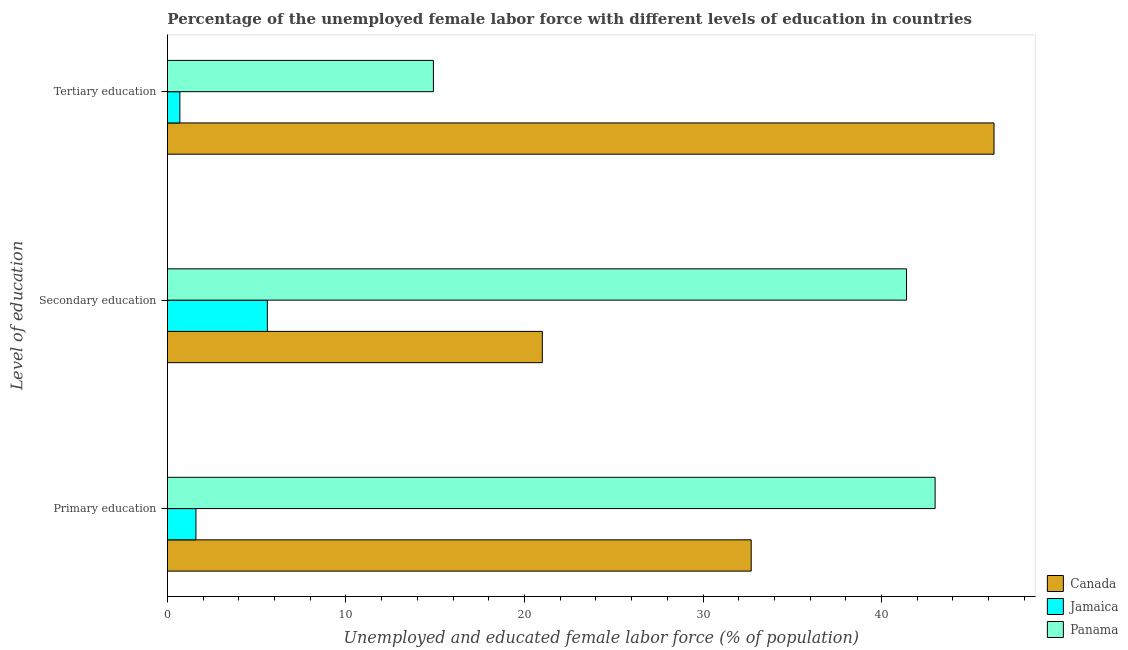How many different coloured bars are there?
Provide a succinct answer. 3. Are the number of bars per tick equal to the number of legend labels?
Make the answer very short. Yes. Are the number of bars on each tick of the Y-axis equal?
Keep it short and to the point. Yes. How many bars are there on the 1st tick from the top?
Ensure brevity in your answer.  3. What is the label of the 2nd group of bars from the top?
Provide a short and direct response. Secondary education. What is the percentage of female labor force who received primary education in Jamaica?
Your answer should be very brief. 1.6. Across all countries, what is the maximum percentage of female labor force who received tertiary education?
Offer a very short reply. 46.3. Across all countries, what is the minimum percentage of female labor force who received tertiary education?
Provide a short and direct response. 0.7. In which country was the percentage of female labor force who received secondary education maximum?
Give a very brief answer. Panama. In which country was the percentage of female labor force who received tertiary education minimum?
Offer a very short reply. Jamaica. What is the total percentage of female labor force who received tertiary education in the graph?
Your answer should be compact. 61.9. What is the difference between the percentage of female labor force who received primary education in Canada and that in Jamaica?
Your response must be concise. 31.1. What is the difference between the percentage of female labor force who received tertiary education in Canada and the percentage of female labor force who received secondary education in Panama?
Provide a short and direct response. 4.9. What is the average percentage of female labor force who received primary education per country?
Ensure brevity in your answer.  25.77. What is the difference between the percentage of female labor force who received secondary education and percentage of female labor force who received tertiary education in Canada?
Your response must be concise. -25.3. What is the ratio of the percentage of female labor force who received primary education in Panama to that in Jamaica?
Offer a very short reply. 26.87. Is the difference between the percentage of female labor force who received primary education in Jamaica and Panama greater than the difference between the percentage of female labor force who received secondary education in Jamaica and Panama?
Ensure brevity in your answer.  No. What is the difference between the highest and the second highest percentage of female labor force who received secondary education?
Offer a terse response. 20.4. What is the difference between the highest and the lowest percentage of female labor force who received tertiary education?
Your answer should be very brief. 45.6. In how many countries, is the percentage of female labor force who received primary education greater than the average percentage of female labor force who received primary education taken over all countries?
Keep it short and to the point. 2. Is the sum of the percentage of female labor force who received tertiary education in Canada and Panama greater than the maximum percentage of female labor force who received primary education across all countries?
Your answer should be compact. Yes. What does the 2nd bar from the top in Secondary education represents?
Give a very brief answer. Jamaica. What does the 1st bar from the bottom in Primary education represents?
Your answer should be compact. Canada. Is it the case that in every country, the sum of the percentage of female labor force who received primary education and percentage of female labor force who received secondary education is greater than the percentage of female labor force who received tertiary education?
Offer a terse response. Yes. Are all the bars in the graph horizontal?
Offer a terse response. Yes. How many countries are there in the graph?
Provide a short and direct response. 3. How many legend labels are there?
Keep it short and to the point. 3. How are the legend labels stacked?
Offer a terse response. Vertical. What is the title of the graph?
Provide a succinct answer. Percentage of the unemployed female labor force with different levels of education in countries. Does "Kazakhstan" appear as one of the legend labels in the graph?
Your answer should be compact. No. What is the label or title of the X-axis?
Make the answer very short. Unemployed and educated female labor force (% of population). What is the label or title of the Y-axis?
Offer a very short reply. Level of education. What is the Unemployed and educated female labor force (% of population) in Canada in Primary education?
Make the answer very short. 32.7. What is the Unemployed and educated female labor force (% of population) in Jamaica in Primary education?
Provide a short and direct response. 1.6. What is the Unemployed and educated female labor force (% of population) of Panama in Primary education?
Provide a short and direct response. 43. What is the Unemployed and educated female labor force (% of population) of Canada in Secondary education?
Provide a short and direct response. 21. What is the Unemployed and educated female labor force (% of population) in Jamaica in Secondary education?
Give a very brief answer. 5.6. What is the Unemployed and educated female labor force (% of population) in Panama in Secondary education?
Give a very brief answer. 41.4. What is the Unemployed and educated female labor force (% of population) of Canada in Tertiary education?
Give a very brief answer. 46.3. What is the Unemployed and educated female labor force (% of population) of Jamaica in Tertiary education?
Your answer should be compact. 0.7. What is the Unemployed and educated female labor force (% of population) of Panama in Tertiary education?
Make the answer very short. 14.9. Across all Level of education, what is the maximum Unemployed and educated female labor force (% of population) of Canada?
Make the answer very short. 46.3. Across all Level of education, what is the maximum Unemployed and educated female labor force (% of population) in Jamaica?
Your answer should be compact. 5.6. Across all Level of education, what is the minimum Unemployed and educated female labor force (% of population) in Jamaica?
Offer a terse response. 0.7. Across all Level of education, what is the minimum Unemployed and educated female labor force (% of population) of Panama?
Give a very brief answer. 14.9. What is the total Unemployed and educated female labor force (% of population) of Panama in the graph?
Offer a terse response. 99.3. What is the difference between the Unemployed and educated female labor force (% of population) of Canada in Primary education and that in Tertiary education?
Your response must be concise. -13.6. What is the difference between the Unemployed and educated female labor force (% of population) of Panama in Primary education and that in Tertiary education?
Your response must be concise. 28.1. What is the difference between the Unemployed and educated female labor force (% of population) in Canada in Secondary education and that in Tertiary education?
Offer a very short reply. -25.3. What is the difference between the Unemployed and educated female labor force (% of population) in Jamaica in Secondary education and that in Tertiary education?
Provide a succinct answer. 4.9. What is the difference between the Unemployed and educated female labor force (% of population) of Canada in Primary education and the Unemployed and educated female labor force (% of population) of Jamaica in Secondary education?
Your answer should be compact. 27.1. What is the difference between the Unemployed and educated female labor force (% of population) in Canada in Primary education and the Unemployed and educated female labor force (% of population) in Panama in Secondary education?
Keep it short and to the point. -8.7. What is the difference between the Unemployed and educated female labor force (% of population) in Jamaica in Primary education and the Unemployed and educated female labor force (% of population) in Panama in Secondary education?
Make the answer very short. -39.8. What is the difference between the Unemployed and educated female labor force (% of population) in Canada in Primary education and the Unemployed and educated female labor force (% of population) in Jamaica in Tertiary education?
Offer a terse response. 32. What is the difference between the Unemployed and educated female labor force (% of population) in Canada in Primary education and the Unemployed and educated female labor force (% of population) in Panama in Tertiary education?
Offer a terse response. 17.8. What is the difference between the Unemployed and educated female labor force (% of population) in Jamaica in Primary education and the Unemployed and educated female labor force (% of population) in Panama in Tertiary education?
Offer a very short reply. -13.3. What is the difference between the Unemployed and educated female labor force (% of population) in Canada in Secondary education and the Unemployed and educated female labor force (% of population) in Jamaica in Tertiary education?
Give a very brief answer. 20.3. What is the difference between the Unemployed and educated female labor force (% of population) in Canada in Secondary education and the Unemployed and educated female labor force (% of population) in Panama in Tertiary education?
Make the answer very short. 6.1. What is the average Unemployed and educated female labor force (% of population) in Canada per Level of education?
Your response must be concise. 33.33. What is the average Unemployed and educated female labor force (% of population) of Jamaica per Level of education?
Provide a succinct answer. 2.63. What is the average Unemployed and educated female labor force (% of population) in Panama per Level of education?
Provide a succinct answer. 33.1. What is the difference between the Unemployed and educated female labor force (% of population) of Canada and Unemployed and educated female labor force (% of population) of Jamaica in Primary education?
Your answer should be compact. 31.1. What is the difference between the Unemployed and educated female labor force (% of population) of Canada and Unemployed and educated female labor force (% of population) of Panama in Primary education?
Provide a short and direct response. -10.3. What is the difference between the Unemployed and educated female labor force (% of population) in Jamaica and Unemployed and educated female labor force (% of population) in Panama in Primary education?
Your response must be concise. -41.4. What is the difference between the Unemployed and educated female labor force (% of population) of Canada and Unemployed and educated female labor force (% of population) of Panama in Secondary education?
Your response must be concise. -20.4. What is the difference between the Unemployed and educated female labor force (% of population) in Jamaica and Unemployed and educated female labor force (% of population) in Panama in Secondary education?
Make the answer very short. -35.8. What is the difference between the Unemployed and educated female labor force (% of population) of Canada and Unemployed and educated female labor force (% of population) of Jamaica in Tertiary education?
Your answer should be compact. 45.6. What is the difference between the Unemployed and educated female labor force (% of population) in Canada and Unemployed and educated female labor force (% of population) in Panama in Tertiary education?
Provide a succinct answer. 31.4. What is the difference between the Unemployed and educated female labor force (% of population) in Jamaica and Unemployed and educated female labor force (% of population) in Panama in Tertiary education?
Offer a very short reply. -14.2. What is the ratio of the Unemployed and educated female labor force (% of population) of Canada in Primary education to that in Secondary education?
Offer a very short reply. 1.56. What is the ratio of the Unemployed and educated female labor force (% of population) in Jamaica in Primary education to that in Secondary education?
Offer a very short reply. 0.29. What is the ratio of the Unemployed and educated female labor force (% of population) of Panama in Primary education to that in Secondary education?
Your answer should be compact. 1.04. What is the ratio of the Unemployed and educated female labor force (% of population) in Canada in Primary education to that in Tertiary education?
Provide a short and direct response. 0.71. What is the ratio of the Unemployed and educated female labor force (% of population) in Jamaica in Primary education to that in Tertiary education?
Offer a terse response. 2.29. What is the ratio of the Unemployed and educated female labor force (% of population) in Panama in Primary education to that in Tertiary education?
Keep it short and to the point. 2.89. What is the ratio of the Unemployed and educated female labor force (% of population) in Canada in Secondary education to that in Tertiary education?
Provide a succinct answer. 0.45. What is the ratio of the Unemployed and educated female labor force (% of population) in Jamaica in Secondary education to that in Tertiary education?
Your answer should be very brief. 8. What is the ratio of the Unemployed and educated female labor force (% of population) of Panama in Secondary education to that in Tertiary education?
Keep it short and to the point. 2.78. What is the difference between the highest and the second highest Unemployed and educated female labor force (% of population) of Canada?
Your answer should be very brief. 13.6. What is the difference between the highest and the lowest Unemployed and educated female labor force (% of population) of Canada?
Make the answer very short. 25.3. What is the difference between the highest and the lowest Unemployed and educated female labor force (% of population) in Panama?
Your answer should be very brief. 28.1. 